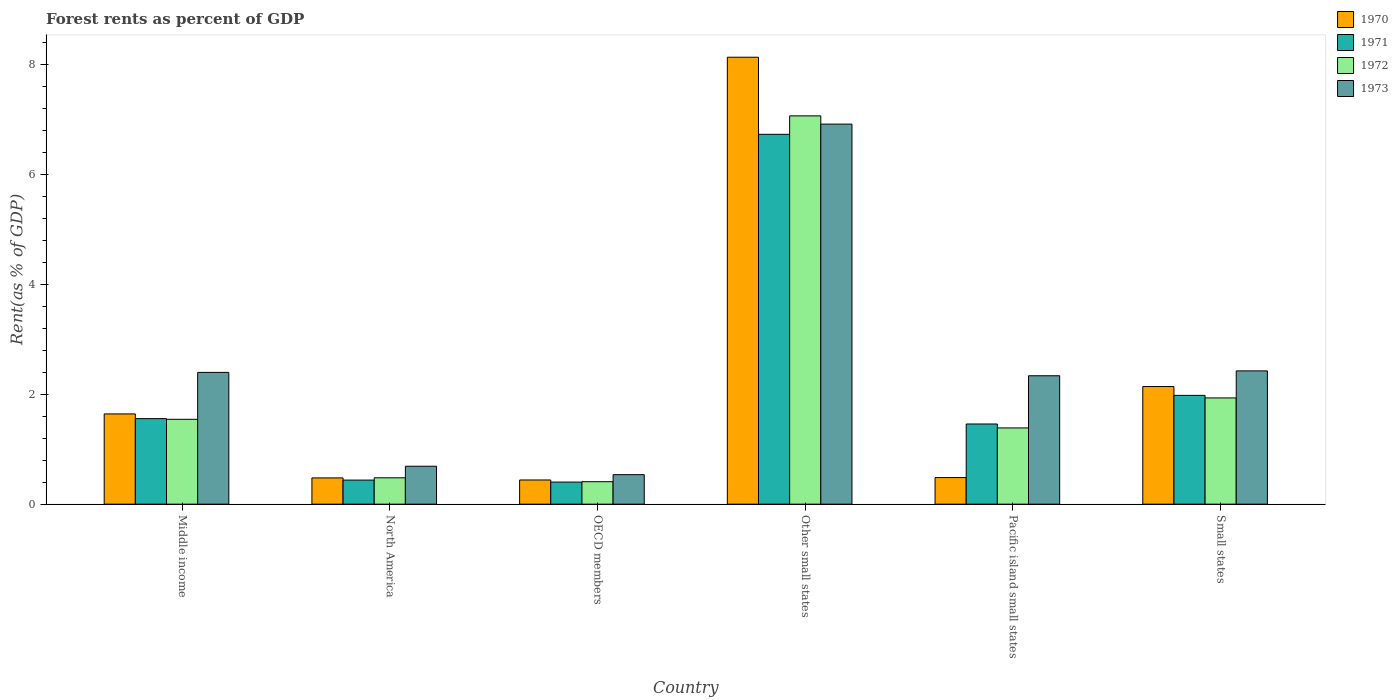How many groups of bars are there?
Ensure brevity in your answer.  6. Are the number of bars per tick equal to the number of legend labels?
Your answer should be very brief. Yes. What is the label of the 6th group of bars from the left?
Keep it short and to the point. Small states. What is the forest rent in 1973 in North America?
Make the answer very short. 0.69. Across all countries, what is the maximum forest rent in 1973?
Offer a very short reply. 6.92. Across all countries, what is the minimum forest rent in 1970?
Ensure brevity in your answer.  0.44. In which country was the forest rent in 1972 maximum?
Provide a short and direct response. Other small states. In which country was the forest rent in 1970 minimum?
Keep it short and to the point. OECD members. What is the total forest rent in 1973 in the graph?
Offer a terse response. 15.31. What is the difference between the forest rent in 1971 in OECD members and that in Small states?
Ensure brevity in your answer.  -1.58. What is the difference between the forest rent in 1971 in North America and the forest rent in 1972 in Middle income?
Offer a terse response. -1.11. What is the average forest rent in 1971 per country?
Keep it short and to the point. 2.09. What is the difference between the forest rent of/in 1971 and forest rent of/in 1972 in North America?
Provide a succinct answer. -0.04. What is the ratio of the forest rent in 1973 in North America to that in Small states?
Your answer should be very brief. 0.28. Is the forest rent in 1972 in OECD members less than that in Small states?
Your response must be concise. Yes. Is the difference between the forest rent in 1971 in North America and OECD members greater than the difference between the forest rent in 1972 in North America and OECD members?
Provide a succinct answer. No. What is the difference between the highest and the second highest forest rent in 1970?
Make the answer very short. 6.49. What is the difference between the highest and the lowest forest rent in 1973?
Give a very brief answer. 6.38. Is it the case that in every country, the sum of the forest rent in 1971 and forest rent in 1970 is greater than the sum of forest rent in 1973 and forest rent in 1972?
Offer a very short reply. No. What does the 2nd bar from the right in Middle income represents?
Your response must be concise. 1972. Is it the case that in every country, the sum of the forest rent in 1971 and forest rent in 1973 is greater than the forest rent in 1970?
Make the answer very short. Yes. Are all the bars in the graph horizontal?
Provide a short and direct response. No. What is the difference between two consecutive major ticks on the Y-axis?
Ensure brevity in your answer.  2. Does the graph contain any zero values?
Your answer should be very brief. No. Does the graph contain grids?
Give a very brief answer. No. What is the title of the graph?
Give a very brief answer. Forest rents as percent of GDP. Does "1961" appear as one of the legend labels in the graph?
Keep it short and to the point. No. What is the label or title of the X-axis?
Your response must be concise. Country. What is the label or title of the Y-axis?
Your answer should be very brief. Rent(as % of GDP). What is the Rent(as % of GDP) in 1970 in Middle income?
Your response must be concise. 1.64. What is the Rent(as % of GDP) in 1971 in Middle income?
Provide a succinct answer. 1.56. What is the Rent(as % of GDP) in 1972 in Middle income?
Your answer should be very brief. 1.54. What is the Rent(as % of GDP) of 1973 in Middle income?
Your response must be concise. 2.4. What is the Rent(as % of GDP) in 1970 in North America?
Keep it short and to the point. 0.48. What is the Rent(as % of GDP) of 1971 in North America?
Ensure brevity in your answer.  0.44. What is the Rent(as % of GDP) in 1972 in North America?
Keep it short and to the point. 0.48. What is the Rent(as % of GDP) in 1973 in North America?
Ensure brevity in your answer.  0.69. What is the Rent(as % of GDP) of 1970 in OECD members?
Your response must be concise. 0.44. What is the Rent(as % of GDP) of 1971 in OECD members?
Ensure brevity in your answer.  0.4. What is the Rent(as % of GDP) in 1972 in OECD members?
Provide a short and direct response. 0.41. What is the Rent(as % of GDP) of 1973 in OECD members?
Ensure brevity in your answer.  0.54. What is the Rent(as % of GDP) of 1970 in Other small states?
Provide a short and direct response. 8.13. What is the Rent(as % of GDP) in 1971 in Other small states?
Keep it short and to the point. 6.73. What is the Rent(as % of GDP) of 1972 in Other small states?
Your answer should be very brief. 7.07. What is the Rent(as % of GDP) of 1973 in Other small states?
Make the answer very short. 6.92. What is the Rent(as % of GDP) of 1970 in Pacific island small states?
Your answer should be compact. 0.48. What is the Rent(as % of GDP) of 1971 in Pacific island small states?
Provide a succinct answer. 1.46. What is the Rent(as % of GDP) in 1972 in Pacific island small states?
Give a very brief answer. 1.39. What is the Rent(as % of GDP) in 1973 in Pacific island small states?
Keep it short and to the point. 2.34. What is the Rent(as % of GDP) in 1970 in Small states?
Make the answer very short. 2.14. What is the Rent(as % of GDP) in 1971 in Small states?
Offer a very short reply. 1.98. What is the Rent(as % of GDP) of 1972 in Small states?
Give a very brief answer. 1.93. What is the Rent(as % of GDP) of 1973 in Small states?
Your response must be concise. 2.43. Across all countries, what is the maximum Rent(as % of GDP) in 1970?
Offer a very short reply. 8.13. Across all countries, what is the maximum Rent(as % of GDP) in 1971?
Ensure brevity in your answer.  6.73. Across all countries, what is the maximum Rent(as % of GDP) of 1972?
Your answer should be compact. 7.07. Across all countries, what is the maximum Rent(as % of GDP) of 1973?
Your response must be concise. 6.92. Across all countries, what is the minimum Rent(as % of GDP) of 1970?
Provide a succinct answer. 0.44. Across all countries, what is the minimum Rent(as % of GDP) of 1971?
Make the answer very short. 0.4. Across all countries, what is the minimum Rent(as % of GDP) of 1972?
Offer a very short reply. 0.41. Across all countries, what is the minimum Rent(as % of GDP) of 1973?
Make the answer very short. 0.54. What is the total Rent(as % of GDP) of 1970 in the graph?
Offer a very short reply. 13.32. What is the total Rent(as % of GDP) of 1971 in the graph?
Give a very brief answer. 12.57. What is the total Rent(as % of GDP) of 1972 in the graph?
Your answer should be compact. 12.82. What is the total Rent(as % of GDP) in 1973 in the graph?
Give a very brief answer. 15.31. What is the difference between the Rent(as % of GDP) of 1970 in Middle income and that in North America?
Your answer should be compact. 1.16. What is the difference between the Rent(as % of GDP) in 1971 in Middle income and that in North America?
Your response must be concise. 1.12. What is the difference between the Rent(as % of GDP) of 1972 in Middle income and that in North America?
Your answer should be very brief. 1.06. What is the difference between the Rent(as % of GDP) of 1973 in Middle income and that in North America?
Your answer should be very brief. 1.71. What is the difference between the Rent(as % of GDP) of 1970 in Middle income and that in OECD members?
Your response must be concise. 1.2. What is the difference between the Rent(as % of GDP) in 1971 in Middle income and that in OECD members?
Offer a terse response. 1.15. What is the difference between the Rent(as % of GDP) in 1972 in Middle income and that in OECD members?
Provide a succinct answer. 1.14. What is the difference between the Rent(as % of GDP) in 1973 in Middle income and that in OECD members?
Provide a succinct answer. 1.86. What is the difference between the Rent(as % of GDP) of 1970 in Middle income and that in Other small states?
Offer a very short reply. -6.49. What is the difference between the Rent(as % of GDP) of 1971 in Middle income and that in Other small states?
Your answer should be very brief. -5.17. What is the difference between the Rent(as % of GDP) in 1972 in Middle income and that in Other small states?
Make the answer very short. -5.52. What is the difference between the Rent(as % of GDP) of 1973 in Middle income and that in Other small states?
Ensure brevity in your answer.  -4.52. What is the difference between the Rent(as % of GDP) in 1970 in Middle income and that in Pacific island small states?
Your answer should be compact. 1.16. What is the difference between the Rent(as % of GDP) of 1971 in Middle income and that in Pacific island small states?
Keep it short and to the point. 0.1. What is the difference between the Rent(as % of GDP) of 1972 in Middle income and that in Pacific island small states?
Provide a succinct answer. 0.16. What is the difference between the Rent(as % of GDP) in 1973 in Middle income and that in Pacific island small states?
Your response must be concise. 0.06. What is the difference between the Rent(as % of GDP) in 1970 in Middle income and that in Small states?
Provide a succinct answer. -0.5. What is the difference between the Rent(as % of GDP) of 1971 in Middle income and that in Small states?
Provide a succinct answer. -0.42. What is the difference between the Rent(as % of GDP) of 1972 in Middle income and that in Small states?
Provide a short and direct response. -0.39. What is the difference between the Rent(as % of GDP) of 1973 in Middle income and that in Small states?
Your answer should be compact. -0.03. What is the difference between the Rent(as % of GDP) of 1970 in North America and that in OECD members?
Give a very brief answer. 0.04. What is the difference between the Rent(as % of GDP) of 1971 in North America and that in OECD members?
Make the answer very short. 0.04. What is the difference between the Rent(as % of GDP) of 1972 in North America and that in OECD members?
Your answer should be compact. 0.07. What is the difference between the Rent(as % of GDP) in 1973 in North America and that in OECD members?
Offer a very short reply. 0.15. What is the difference between the Rent(as % of GDP) in 1970 in North America and that in Other small states?
Your response must be concise. -7.66. What is the difference between the Rent(as % of GDP) of 1971 in North America and that in Other small states?
Offer a terse response. -6.29. What is the difference between the Rent(as % of GDP) in 1972 in North America and that in Other small states?
Give a very brief answer. -6.59. What is the difference between the Rent(as % of GDP) in 1973 in North America and that in Other small states?
Keep it short and to the point. -6.23. What is the difference between the Rent(as % of GDP) of 1970 in North America and that in Pacific island small states?
Make the answer very short. -0.01. What is the difference between the Rent(as % of GDP) in 1971 in North America and that in Pacific island small states?
Offer a very short reply. -1.02. What is the difference between the Rent(as % of GDP) of 1972 in North America and that in Pacific island small states?
Offer a very short reply. -0.91. What is the difference between the Rent(as % of GDP) in 1973 in North America and that in Pacific island small states?
Provide a succinct answer. -1.65. What is the difference between the Rent(as % of GDP) in 1970 in North America and that in Small states?
Your answer should be very brief. -1.66. What is the difference between the Rent(as % of GDP) of 1971 in North America and that in Small states?
Provide a short and direct response. -1.54. What is the difference between the Rent(as % of GDP) of 1972 in North America and that in Small states?
Provide a short and direct response. -1.45. What is the difference between the Rent(as % of GDP) in 1973 in North America and that in Small states?
Keep it short and to the point. -1.74. What is the difference between the Rent(as % of GDP) of 1970 in OECD members and that in Other small states?
Provide a short and direct response. -7.69. What is the difference between the Rent(as % of GDP) in 1971 in OECD members and that in Other small states?
Your response must be concise. -6.33. What is the difference between the Rent(as % of GDP) of 1972 in OECD members and that in Other small states?
Your answer should be very brief. -6.66. What is the difference between the Rent(as % of GDP) of 1973 in OECD members and that in Other small states?
Your response must be concise. -6.38. What is the difference between the Rent(as % of GDP) in 1970 in OECD members and that in Pacific island small states?
Your answer should be very brief. -0.04. What is the difference between the Rent(as % of GDP) in 1971 in OECD members and that in Pacific island small states?
Keep it short and to the point. -1.06. What is the difference between the Rent(as % of GDP) in 1972 in OECD members and that in Pacific island small states?
Keep it short and to the point. -0.98. What is the difference between the Rent(as % of GDP) of 1973 in OECD members and that in Pacific island small states?
Your answer should be very brief. -1.8. What is the difference between the Rent(as % of GDP) of 1970 in OECD members and that in Small states?
Offer a very short reply. -1.7. What is the difference between the Rent(as % of GDP) of 1971 in OECD members and that in Small states?
Your response must be concise. -1.58. What is the difference between the Rent(as % of GDP) of 1972 in OECD members and that in Small states?
Offer a terse response. -1.52. What is the difference between the Rent(as % of GDP) in 1973 in OECD members and that in Small states?
Your answer should be very brief. -1.89. What is the difference between the Rent(as % of GDP) of 1970 in Other small states and that in Pacific island small states?
Your answer should be compact. 7.65. What is the difference between the Rent(as % of GDP) of 1971 in Other small states and that in Pacific island small states?
Make the answer very short. 5.27. What is the difference between the Rent(as % of GDP) of 1972 in Other small states and that in Pacific island small states?
Give a very brief answer. 5.68. What is the difference between the Rent(as % of GDP) in 1973 in Other small states and that in Pacific island small states?
Make the answer very short. 4.58. What is the difference between the Rent(as % of GDP) of 1970 in Other small states and that in Small states?
Ensure brevity in your answer.  5.99. What is the difference between the Rent(as % of GDP) in 1971 in Other small states and that in Small states?
Offer a very short reply. 4.75. What is the difference between the Rent(as % of GDP) in 1972 in Other small states and that in Small states?
Provide a succinct answer. 5.13. What is the difference between the Rent(as % of GDP) in 1973 in Other small states and that in Small states?
Your answer should be compact. 4.49. What is the difference between the Rent(as % of GDP) in 1970 in Pacific island small states and that in Small states?
Keep it short and to the point. -1.66. What is the difference between the Rent(as % of GDP) in 1971 in Pacific island small states and that in Small states?
Offer a terse response. -0.52. What is the difference between the Rent(as % of GDP) of 1972 in Pacific island small states and that in Small states?
Your response must be concise. -0.55. What is the difference between the Rent(as % of GDP) of 1973 in Pacific island small states and that in Small states?
Offer a very short reply. -0.09. What is the difference between the Rent(as % of GDP) in 1970 in Middle income and the Rent(as % of GDP) in 1971 in North America?
Give a very brief answer. 1.2. What is the difference between the Rent(as % of GDP) in 1970 in Middle income and the Rent(as % of GDP) in 1972 in North America?
Make the answer very short. 1.16. What is the difference between the Rent(as % of GDP) in 1970 in Middle income and the Rent(as % of GDP) in 1973 in North America?
Give a very brief answer. 0.95. What is the difference between the Rent(as % of GDP) of 1971 in Middle income and the Rent(as % of GDP) of 1973 in North America?
Give a very brief answer. 0.87. What is the difference between the Rent(as % of GDP) of 1972 in Middle income and the Rent(as % of GDP) of 1973 in North America?
Keep it short and to the point. 0.85. What is the difference between the Rent(as % of GDP) of 1970 in Middle income and the Rent(as % of GDP) of 1971 in OECD members?
Provide a short and direct response. 1.24. What is the difference between the Rent(as % of GDP) of 1970 in Middle income and the Rent(as % of GDP) of 1972 in OECD members?
Your response must be concise. 1.23. What is the difference between the Rent(as % of GDP) in 1970 in Middle income and the Rent(as % of GDP) in 1973 in OECD members?
Ensure brevity in your answer.  1.11. What is the difference between the Rent(as % of GDP) in 1971 in Middle income and the Rent(as % of GDP) in 1972 in OECD members?
Offer a very short reply. 1.15. What is the difference between the Rent(as % of GDP) in 1971 in Middle income and the Rent(as % of GDP) in 1973 in OECD members?
Provide a succinct answer. 1.02. What is the difference between the Rent(as % of GDP) of 1972 in Middle income and the Rent(as % of GDP) of 1973 in OECD members?
Ensure brevity in your answer.  1.01. What is the difference between the Rent(as % of GDP) in 1970 in Middle income and the Rent(as % of GDP) in 1971 in Other small states?
Make the answer very short. -5.09. What is the difference between the Rent(as % of GDP) in 1970 in Middle income and the Rent(as % of GDP) in 1972 in Other small states?
Provide a short and direct response. -5.42. What is the difference between the Rent(as % of GDP) in 1970 in Middle income and the Rent(as % of GDP) in 1973 in Other small states?
Keep it short and to the point. -5.27. What is the difference between the Rent(as % of GDP) in 1971 in Middle income and the Rent(as % of GDP) in 1972 in Other small states?
Give a very brief answer. -5.51. What is the difference between the Rent(as % of GDP) in 1971 in Middle income and the Rent(as % of GDP) in 1973 in Other small states?
Offer a terse response. -5.36. What is the difference between the Rent(as % of GDP) of 1972 in Middle income and the Rent(as % of GDP) of 1973 in Other small states?
Provide a succinct answer. -5.37. What is the difference between the Rent(as % of GDP) of 1970 in Middle income and the Rent(as % of GDP) of 1971 in Pacific island small states?
Ensure brevity in your answer.  0.18. What is the difference between the Rent(as % of GDP) of 1970 in Middle income and the Rent(as % of GDP) of 1972 in Pacific island small states?
Provide a succinct answer. 0.25. What is the difference between the Rent(as % of GDP) of 1970 in Middle income and the Rent(as % of GDP) of 1973 in Pacific island small states?
Provide a succinct answer. -0.69. What is the difference between the Rent(as % of GDP) of 1971 in Middle income and the Rent(as % of GDP) of 1972 in Pacific island small states?
Provide a short and direct response. 0.17. What is the difference between the Rent(as % of GDP) in 1971 in Middle income and the Rent(as % of GDP) in 1973 in Pacific island small states?
Offer a terse response. -0.78. What is the difference between the Rent(as % of GDP) of 1972 in Middle income and the Rent(as % of GDP) of 1973 in Pacific island small states?
Your answer should be very brief. -0.79. What is the difference between the Rent(as % of GDP) in 1970 in Middle income and the Rent(as % of GDP) in 1971 in Small states?
Offer a terse response. -0.34. What is the difference between the Rent(as % of GDP) of 1970 in Middle income and the Rent(as % of GDP) of 1972 in Small states?
Offer a very short reply. -0.29. What is the difference between the Rent(as % of GDP) in 1970 in Middle income and the Rent(as % of GDP) in 1973 in Small states?
Offer a terse response. -0.78. What is the difference between the Rent(as % of GDP) in 1971 in Middle income and the Rent(as % of GDP) in 1972 in Small states?
Offer a terse response. -0.38. What is the difference between the Rent(as % of GDP) in 1971 in Middle income and the Rent(as % of GDP) in 1973 in Small states?
Provide a succinct answer. -0.87. What is the difference between the Rent(as % of GDP) of 1972 in Middle income and the Rent(as % of GDP) of 1973 in Small states?
Ensure brevity in your answer.  -0.88. What is the difference between the Rent(as % of GDP) in 1970 in North America and the Rent(as % of GDP) in 1971 in OECD members?
Offer a terse response. 0.08. What is the difference between the Rent(as % of GDP) in 1970 in North America and the Rent(as % of GDP) in 1972 in OECD members?
Your answer should be very brief. 0.07. What is the difference between the Rent(as % of GDP) in 1970 in North America and the Rent(as % of GDP) in 1973 in OECD members?
Make the answer very short. -0.06. What is the difference between the Rent(as % of GDP) of 1971 in North America and the Rent(as % of GDP) of 1972 in OECD members?
Provide a short and direct response. 0.03. What is the difference between the Rent(as % of GDP) of 1971 in North America and the Rent(as % of GDP) of 1973 in OECD members?
Offer a very short reply. -0.1. What is the difference between the Rent(as % of GDP) of 1972 in North America and the Rent(as % of GDP) of 1973 in OECD members?
Your response must be concise. -0.06. What is the difference between the Rent(as % of GDP) in 1970 in North America and the Rent(as % of GDP) in 1971 in Other small states?
Your response must be concise. -6.25. What is the difference between the Rent(as % of GDP) of 1970 in North America and the Rent(as % of GDP) of 1972 in Other small states?
Your answer should be very brief. -6.59. What is the difference between the Rent(as % of GDP) in 1970 in North America and the Rent(as % of GDP) in 1973 in Other small states?
Provide a succinct answer. -6.44. What is the difference between the Rent(as % of GDP) in 1971 in North America and the Rent(as % of GDP) in 1972 in Other small states?
Provide a succinct answer. -6.63. What is the difference between the Rent(as % of GDP) of 1971 in North America and the Rent(as % of GDP) of 1973 in Other small states?
Make the answer very short. -6.48. What is the difference between the Rent(as % of GDP) in 1972 in North America and the Rent(as % of GDP) in 1973 in Other small states?
Provide a short and direct response. -6.44. What is the difference between the Rent(as % of GDP) of 1970 in North America and the Rent(as % of GDP) of 1971 in Pacific island small states?
Ensure brevity in your answer.  -0.98. What is the difference between the Rent(as % of GDP) of 1970 in North America and the Rent(as % of GDP) of 1972 in Pacific island small states?
Offer a terse response. -0.91. What is the difference between the Rent(as % of GDP) of 1970 in North America and the Rent(as % of GDP) of 1973 in Pacific island small states?
Make the answer very short. -1.86. What is the difference between the Rent(as % of GDP) in 1971 in North America and the Rent(as % of GDP) in 1972 in Pacific island small states?
Your response must be concise. -0.95. What is the difference between the Rent(as % of GDP) in 1971 in North America and the Rent(as % of GDP) in 1973 in Pacific island small states?
Your answer should be compact. -1.9. What is the difference between the Rent(as % of GDP) of 1972 in North America and the Rent(as % of GDP) of 1973 in Pacific island small states?
Give a very brief answer. -1.86. What is the difference between the Rent(as % of GDP) in 1970 in North America and the Rent(as % of GDP) in 1971 in Small states?
Your answer should be very brief. -1.5. What is the difference between the Rent(as % of GDP) of 1970 in North America and the Rent(as % of GDP) of 1972 in Small states?
Offer a very short reply. -1.46. What is the difference between the Rent(as % of GDP) in 1970 in North America and the Rent(as % of GDP) in 1973 in Small states?
Offer a very short reply. -1.95. What is the difference between the Rent(as % of GDP) in 1971 in North America and the Rent(as % of GDP) in 1972 in Small states?
Provide a succinct answer. -1.5. What is the difference between the Rent(as % of GDP) of 1971 in North America and the Rent(as % of GDP) of 1973 in Small states?
Keep it short and to the point. -1.99. What is the difference between the Rent(as % of GDP) of 1972 in North America and the Rent(as % of GDP) of 1973 in Small states?
Give a very brief answer. -1.95. What is the difference between the Rent(as % of GDP) in 1970 in OECD members and the Rent(as % of GDP) in 1971 in Other small states?
Your answer should be compact. -6.29. What is the difference between the Rent(as % of GDP) of 1970 in OECD members and the Rent(as % of GDP) of 1972 in Other small states?
Provide a succinct answer. -6.63. What is the difference between the Rent(as % of GDP) in 1970 in OECD members and the Rent(as % of GDP) in 1973 in Other small states?
Give a very brief answer. -6.48. What is the difference between the Rent(as % of GDP) of 1971 in OECD members and the Rent(as % of GDP) of 1972 in Other small states?
Offer a terse response. -6.67. What is the difference between the Rent(as % of GDP) in 1971 in OECD members and the Rent(as % of GDP) in 1973 in Other small states?
Offer a very short reply. -6.52. What is the difference between the Rent(as % of GDP) of 1972 in OECD members and the Rent(as % of GDP) of 1973 in Other small states?
Offer a very short reply. -6.51. What is the difference between the Rent(as % of GDP) of 1970 in OECD members and the Rent(as % of GDP) of 1971 in Pacific island small states?
Make the answer very short. -1.02. What is the difference between the Rent(as % of GDP) of 1970 in OECD members and the Rent(as % of GDP) of 1972 in Pacific island small states?
Make the answer very short. -0.95. What is the difference between the Rent(as % of GDP) in 1970 in OECD members and the Rent(as % of GDP) in 1973 in Pacific island small states?
Your answer should be compact. -1.9. What is the difference between the Rent(as % of GDP) of 1971 in OECD members and the Rent(as % of GDP) of 1972 in Pacific island small states?
Give a very brief answer. -0.99. What is the difference between the Rent(as % of GDP) in 1971 in OECD members and the Rent(as % of GDP) in 1973 in Pacific island small states?
Provide a succinct answer. -1.94. What is the difference between the Rent(as % of GDP) of 1972 in OECD members and the Rent(as % of GDP) of 1973 in Pacific island small states?
Keep it short and to the point. -1.93. What is the difference between the Rent(as % of GDP) in 1970 in OECD members and the Rent(as % of GDP) in 1971 in Small states?
Provide a succinct answer. -1.54. What is the difference between the Rent(as % of GDP) of 1970 in OECD members and the Rent(as % of GDP) of 1972 in Small states?
Provide a succinct answer. -1.49. What is the difference between the Rent(as % of GDP) in 1970 in OECD members and the Rent(as % of GDP) in 1973 in Small states?
Offer a very short reply. -1.99. What is the difference between the Rent(as % of GDP) in 1971 in OECD members and the Rent(as % of GDP) in 1972 in Small states?
Provide a short and direct response. -1.53. What is the difference between the Rent(as % of GDP) in 1971 in OECD members and the Rent(as % of GDP) in 1973 in Small states?
Ensure brevity in your answer.  -2.02. What is the difference between the Rent(as % of GDP) in 1972 in OECD members and the Rent(as % of GDP) in 1973 in Small states?
Keep it short and to the point. -2.02. What is the difference between the Rent(as % of GDP) of 1970 in Other small states and the Rent(as % of GDP) of 1971 in Pacific island small states?
Your answer should be compact. 6.68. What is the difference between the Rent(as % of GDP) of 1970 in Other small states and the Rent(as % of GDP) of 1972 in Pacific island small states?
Make the answer very short. 6.75. What is the difference between the Rent(as % of GDP) in 1970 in Other small states and the Rent(as % of GDP) in 1973 in Pacific island small states?
Give a very brief answer. 5.8. What is the difference between the Rent(as % of GDP) in 1971 in Other small states and the Rent(as % of GDP) in 1972 in Pacific island small states?
Your answer should be compact. 5.34. What is the difference between the Rent(as % of GDP) of 1971 in Other small states and the Rent(as % of GDP) of 1973 in Pacific island small states?
Provide a short and direct response. 4.39. What is the difference between the Rent(as % of GDP) in 1972 in Other small states and the Rent(as % of GDP) in 1973 in Pacific island small states?
Your answer should be compact. 4.73. What is the difference between the Rent(as % of GDP) in 1970 in Other small states and the Rent(as % of GDP) in 1971 in Small states?
Keep it short and to the point. 6.15. What is the difference between the Rent(as % of GDP) of 1970 in Other small states and the Rent(as % of GDP) of 1972 in Small states?
Make the answer very short. 6.2. What is the difference between the Rent(as % of GDP) of 1970 in Other small states and the Rent(as % of GDP) of 1973 in Small states?
Keep it short and to the point. 5.71. What is the difference between the Rent(as % of GDP) of 1971 in Other small states and the Rent(as % of GDP) of 1972 in Small states?
Make the answer very short. 4.8. What is the difference between the Rent(as % of GDP) in 1971 in Other small states and the Rent(as % of GDP) in 1973 in Small states?
Your answer should be very brief. 4.31. What is the difference between the Rent(as % of GDP) of 1972 in Other small states and the Rent(as % of GDP) of 1973 in Small states?
Keep it short and to the point. 4.64. What is the difference between the Rent(as % of GDP) of 1970 in Pacific island small states and the Rent(as % of GDP) of 1971 in Small states?
Offer a very short reply. -1.5. What is the difference between the Rent(as % of GDP) in 1970 in Pacific island small states and the Rent(as % of GDP) in 1972 in Small states?
Provide a succinct answer. -1.45. What is the difference between the Rent(as % of GDP) of 1970 in Pacific island small states and the Rent(as % of GDP) of 1973 in Small states?
Offer a very short reply. -1.94. What is the difference between the Rent(as % of GDP) in 1971 in Pacific island small states and the Rent(as % of GDP) in 1972 in Small states?
Your answer should be compact. -0.47. What is the difference between the Rent(as % of GDP) of 1971 in Pacific island small states and the Rent(as % of GDP) of 1973 in Small states?
Keep it short and to the point. -0.97. What is the difference between the Rent(as % of GDP) in 1972 in Pacific island small states and the Rent(as % of GDP) in 1973 in Small states?
Your response must be concise. -1.04. What is the average Rent(as % of GDP) in 1970 per country?
Your response must be concise. 2.22. What is the average Rent(as % of GDP) of 1971 per country?
Your response must be concise. 2.09. What is the average Rent(as % of GDP) of 1972 per country?
Provide a succinct answer. 2.14. What is the average Rent(as % of GDP) of 1973 per country?
Offer a terse response. 2.55. What is the difference between the Rent(as % of GDP) in 1970 and Rent(as % of GDP) in 1971 in Middle income?
Your answer should be very brief. 0.09. What is the difference between the Rent(as % of GDP) of 1970 and Rent(as % of GDP) of 1972 in Middle income?
Keep it short and to the point. 0.1. What is the difference between the Rent(as % of GDP) in 1970 and Rent(as % of GDP) in 1973 in Middle income?
Your response must be concise. -0.76. What is the difference between the Rent(as % of GDP) of 1971 and Rent(as % of GDP) of 1972 in Middle income?
Your answer should be very brief. 0.01. What is the difference between the Rent(as % of GDP) in 1971 and Rent(as % of GDP) in 1973 in Middle income?
Ensure brevity in your answer.  -0.84. What is the difference between the Rent(as % of GDP) of 1972 and Rent(as % of GDP) of 1973 in Middle income?
Provide a succinct answer. -0.85. What is the difference between the Rent(as % of GDP) in 1970 and Rent(as % of GDP) in 1971 in North America?
Give a very brief answer. 0.04. What is the difference between the Rent(as % of GDP) of 1970 and Rent(as % of GDP) of 1972 in North America?
Make the answer very short. -0. What is the difference between the Rent(as % of GDP) of 1970 and Rent(as % of GDP) of 1973 in North America?
Give a very brief answer. -0.21. What is the difference between the Rent(as % of GDP) of 1971 and Rent(as % of GDP) of 1972 in North America?
Your answer should be compact. -0.04. What is the difference between the Rent(as % of GDP) of 1971 and Rent(as % of GDP) of 1973 in North America?
Ensure brevity in your answer.  -0.25. What is the difference between the Rent(as % of GDP) in 1972 and Rent(as % of GDP) in 1973 in North America?
Provide a succinct answer. -0.21. What is the difference between the Rent(as % of GDP) in 1970 and Rent(as % of GDP) in 1971 in OECD members?
Offer a terse response. 0.04. What is the difference between the Rent(as % of GDP) of 1970 and Rent(as % of GDP) of 1972 in OECD members?
Your answer should be very brief. 0.03. What is the difference between the Rent(as % of GDP) in 1970 and Rent(as % of GDP) in 1973 in OECD members?
Ensure brevity in your answer.  -0.1. What is the difference between the Rent(as % of GDP) in 1971 and Rent(as % of GDP) in 1972 in OECD members?
Your response must be concise. -0.01. What is the difference between the Rent(as % of GDP) in 1971 and Rent(as % of GDP) in 1973 in OECD members?
Ensure brevity in your answer.  -0.14. What is the difference between the Rent(as % of GDP) in 1972 and Rent(as % of GDP) in 1973 in OECD members?
Keep it short and to the point. -0.13. What is the difference between the Rent(as % of GDP) of 1970 and Rent(as % of GDP) of 1971 in Other small states?
Provide a succinct answer. 1.4. What is the difference between the Rent(as % of GDP) in 1970 and Rent(as % of GDP) in 1972 in Other small states?
Ensure brevity in your answer.  1.07. What is the difference between the Rent(as % of GDP) of 1970 and Rent(as % of GDP) of 1973 in Other small states?
Offer a terse response. 1.22. What is the difference between the Rent(as % of GDP) of 1971 and Rent(as % of GDP) of 1972 in Other small states?
Give a very brief answer. -0.34. What is the difference between the Rent(as % of GDP) in 1971 and Rent(as % of GDP) in 1973 in Other small states?
Offer a very short reply. -0.19. What is the difference between the Rent(as % of GDP) of 1972 and Rent(as % of GDP) of 1973 in Other small states?
Keep it short and to the point. 0.15. What is the difference between the Rent(as % of GDP) of 1970 and Rent(as % of GDP) of 1971 in Pacific island small states?
Your answer should be compact. -0.98. What is the difference between the Rent(as % of GDP) of 1970 and Rent(as % of GDP) of 1972 in Pacific island small states?
Keep it short and to the point. -0.9. What is the difference between the Rent(as % of GDP) in 1970 and Rent(as % of GDP) in 1973 in Pacific island small states?
Keep it short and to the point. -1.85. What is the difference between the Rent(as % of GDP) in 1971 and Rent(as % of GDP) in 1972 in Pacific island small states?
Provide a short and direct response. 0.07. What is the difference between the Rent(as % of GDP) of 1971 and Rent(as % of GDP) of 1973 in Pacific island small states?
Ensure brevity in your answer.  -0.88. What is the difference between the Rent(as % of GDP) in 1972 and Rent(as % of GDP) in 1973 in Pacific island small states?
Give a very brief answer. -0.95. What is the difference between the Rent(as % of GDP) in 1970 and Rent(as % of GDP) in 1971 in Small states?
Your answer should be very brief. 0.16. What is the difference between the Rent(as % of GDP) of 1970 and Rent(as % of GDP) of 1972 in Small states?
Your response must be concise. 0.21. What is the difference between the Rent(as % of GDP) of 1970 and Rent(as % of GDP) of 1973 in Small states?
Provide a succinct answer. -0.29. What is the difference between the Rent(as % of GDP) of 1971 and Rent(as % of GDP) of 1972 in Small states?
Keep it short and to the point. 0.05. What is the difference between the Rent(as % of GDP) in 1971 and Rent(as % of GDP) in 1973 in Small states?
Your answer should be compact. -0.45. What is the difference between the Rent(as % of GDP) of 1972 and Rent(as % of GDP) of 1973 in Small states?
Provide a short and direct response. -0.49. What is the ratio of the Rent(as % of GDP) of 1970 in Middle income to that in North America?
Offer a terse response. 3.44. What is the ratio of the Rent(as % of GDP) of 1971 in Middle income to that in North America?
Offer a very short reply. 3.55. What is the ratio of the Rent(as % of GDP) of 1972 in Middle income to that in North America?
Make the answer very short. 3.22. What is the ratio of the Rent(as % of GDP) of 1973 in Middle income to that in North America?
Your answer should be compact. 3.47. What is the ratio of the Rent(as % of GDP) in 1970 in Middle income to that in OECD members?
Give a very brief answer. 3.73. What is the ratio of the Rent(as % of GDP) of 1971 in Middle income to that in OECD members?
Keep it short and to the point. 3.88. What is the ratio of the Rent(as % of GDP) in 1972 in Middle income to that in OECD members?
Offer a very short reply. 3.78. What is the ratio of the Rent(as % of GDP) in 1973 in Middle income to that in OECD members?
Your answer should be compact. 4.47. What is the ratio of the Rent(as % of GDP) of 1970 in Middle income to that in Other small states?
Your answer should be very brief. 0.2. What is the ratio of the Rent(as % of GDP) of 1971 in Middle income to that in Other small states?
Offer a terse response. 0.23. What is the ratio of the Rent(as % of GDP) in 1972 in Middle income to that in Other small states?
Your answer should be compact. 0.22. What is the ratio of the Rent(as % of GDP) of 1973 in Middle income to that in Other small states?
Your answer should be very brief. 0.35. What is the ratio of the Rent(as % of GDP) of 1970 in Middle income to that in Pacific island small states?
Give a very brief answer. 3.4. What is the ratio of the Rent(as % of GDP) of 1971 in Middle income to that in Pacific island small states?
Your answer should be very brief. 1.07. What is the ratio of the Rent(as % of GDP) of 1972 in Middle income to that in Pacific island small states?
Keep it short and to the point. 1.11. What is the ratio of the Rent(as % of GDP) in 1973 in Middle income to that in Pacific island small states?
Make the answer very short. 1.03. What is the ratio of the Rent(as % of GDP) of 1970 in Middle income to that in Small states?
Give a very brief answer. 0.77. What is the ratio of the Rent(as % of GDP) of 1971 in Middle income to that in Small states?
Give a very brief answer. 0.79. What is the ratio of the Rent(as % of GDP) in 1972 in Middle income to that in Small states?
Provide a short and direct response. 0.8. What is the ratio of the Rent(as % of GDP) of 1970 in North America to that in OECD members?
Ensure brevity in your answer.  1.09. What is the ratio of the Rent(as % of GDP) in 1971 in North America to that in OECD members?
Provide a short and direct response. 1.09. What is the ratio of the Rent(as % of GDP) of 1972 in North America to that in OECD members?
Provide a short and direct response. 1.17. What is the ratio of the Rent(as % of GDP) of 1973 in North America to that in OECD members?
Provide a succinct answer. 1.29. What is the ratio of the Rent(as % of GDP) of 1970 in North America to that in Other small states?
Your response must be concise. 0.06. What is the ratio of the Rent(as % of GDP) in 1971 in North America to that in Other small states?
Your answer should be compact. 0.07. What is the ratio of the Rent(as % of GDP) in 1972 in North America to that in Other small states?
Make the answer very short. 0.07. What is the ratio of the Rent(as % of GDP) in 1973 in North America to that in Other small states?
Offer a terse response. 0.1. What is the ratio of the Rent(as % of GDP) in 1971 in North America to that in Pacific island small states?
Offer a very short reply. 0.3. What is the ratio of the Rent(as % of GDP) in 1972 in North America to that in Pacific island small states?
Your answer should be compact. 0.35. What is the ratio of the Rent(as % of GDP) of 1973 in North America to that in Pacific island small states?
Keep it short and to the point. 0.3. What is the ratio of the Rent(as % of GDP) in 1970 in North America to that in Small states?
Provide a short and direct response. 0.22. What is the ratio of the Rent(as % of GDP) in 1971 in North America to that in Small states?
Offer a very short reply. 0.22. What is the ratio of the Rent(as % of GDP) of 1972 in North America to that in Small states?
Your response must be concise. 0.25. What is the ratio of the Rent(as % of GDP) of 1973 in North America to that in Small states?
Your answer should be very brief. 0.28. What is the ratio of the Rent(as % of GDP) of 1970 in OECD members to that in Other small states?
Your response must be concise. 0.05. What is the ratio of the Rent(as % of GDP) of 1971 in OECD members to that in Other small states?
Offer a terse response. 0.06. What is the ratio of the Rent(as % of GDP) in 1972 in OECD members to that in Other small states?
Ensure brevity in your answer.  0.06. What is the ratio of the Rent(as % of GDP) in 1973 in OECD members to that in Other small states?
Make the answer very short. 0.08. What is the ratio of the Rent(as % of GDP) in 1970 in OECD members to that in Pacific island small states?
Offer a terse response. 0.91. What is the ratio of the Rent(as % of GDP) in 1971 in OECD members to that in Pacific island small states?
Provide a short and direct response. 0.28. What is the ratio of the Rent(as % of GDP) in 1972 in OECD members to that in Pacific island small states?
Your answer should be very brief. 0.29. What is the ratio of the Rent(as % of GDP) in 1973 in OECD members to that in Pacific island small states?
Make the answer very short. 0.23. What is the ratio of the Rent(as % of GDP) in 1970 in OECD members to that in Small states?
Provide a succinct answer. 0.21. What is the ratio of the Rent(as % of GDP) in 1971 in OECD members to that in Small states?
Offer a very short reply. 0.2. What is the ratio of the Rent(as % of GDP) of 1972 in OECD members to that in Small states?
Provide a short and direct response. 0.21. What is the ratio of the Rent(as % of GDP) of 1973 in OECD members to that in Small states?
Offer a terse response. 0.22. What is the ratio of the Rent(as % of GDP) of 1970 in Other small states to that in Pacific island small states?
Make the answer very short. 16.82. What is the ratio of the Rent(as % of GDP) in 1971 in Other small states to that in Pacific island small states?
Provide a succinct answer. 4.61. What is the ratio of the Rent(as % of GDP) in 1972 in Other small states to that in Pacific island small states?
Provide a short and direct response. 5.09. What is the ratio of the Rent(as % of GDP) in 1973 in Other small states to that in Pacific island small states?
Offer a very short reply. 2.96. What is the ratio of the Rent(as % of GDP) in 1970 in Other small states to that in Small states?
Offer a very short reply. 3.8. What is the ratio of the Rent(as % of GDP) of 1971 in Other small states to that in Small states?
Ensure brevity in your answer.  3.4. What is the ratio of the Rent(as % of GDP) of 1972 in Other small states to that in Small states?
Offer a very short reply. 3.66. What is the ratio of the Rent(as % of GDP) in 1973 in Other small states to that in Small states?
Your answer should be very brief. 2.85. What is the ratio of the Rent(as % of GDP) in 1970 in Pacific island small states to that in Small states?
Ensure brevity in your answer.  0.23. What is the ratio of the Rent(as % of GDP) in 1971 in Pacific island small states to that in Small states?
Offer a very short reply. 0.74. What is the ratio of the Rent(as % of GDP) in 1972 in Pacific island small states to that in Small states?
Ensure brevity in your answer.  0.72. What is the ratio of the Rent(as % of GDP) in 1973 in Pacific island small states to that in Small states?
Keep it short and to the point. 0.96. What is the difference between the highest and the second highest Rent(as % of GDP) in 1970?
Offer a terse response. 5.99. What is the difference between the highest and the second highest Rent(as % of GDP) in 1971?
Provide a short and direct response. 4.75. What is the difference between the highest and the second highest Rent(as % of GDP) in 1972?
Offer a terse response. 5.13. What is the difference between the highest and the second highest Rent(as % of GDP) of 1973?
Provide a short and direct response. 4.49. What is the difference between the highest and the lowest Rent(as % of GDP) of 1970?
Ensure brevity in your answer.  7.69. What is the difference between the highest and the lowest Rent(as % of GDP) in 1971?
Offer a terse response. 6.33. What is the difference between the highest and the lowest Rent(as % of GDP) in 1972?
Make the answer very short. 6.66. What is the difference between the highest and the lowest Rent(as % of GDP) of 1973?
Offer a terse response. 6.38. 